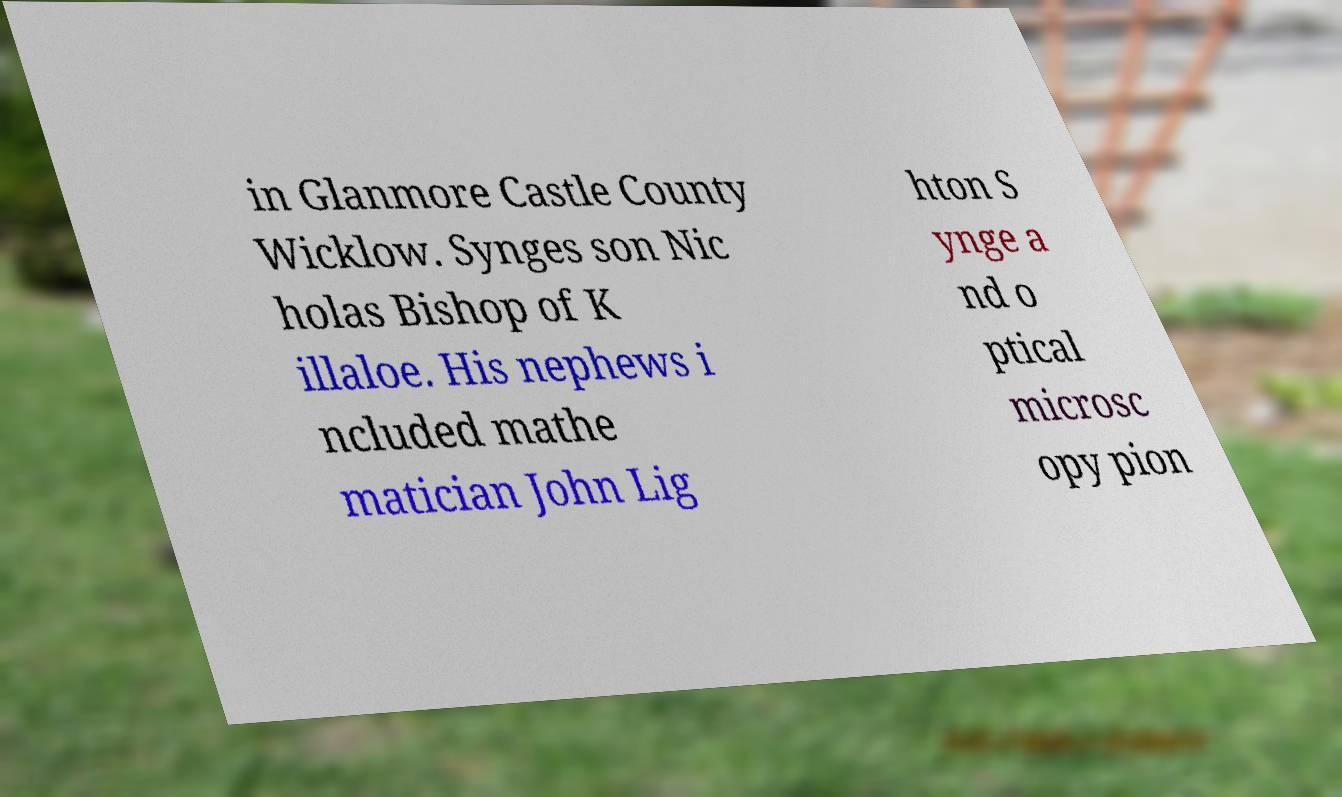For documentation purposes, I need the text within this image transcribed. Could you provide that? in Glanmore Castle County Wicklow. Synges son Nic holas Bishop of K illaloe. His nephews i ncluded mathe matician John Lig hton S ynge a nd o ptical microsc opy pion 